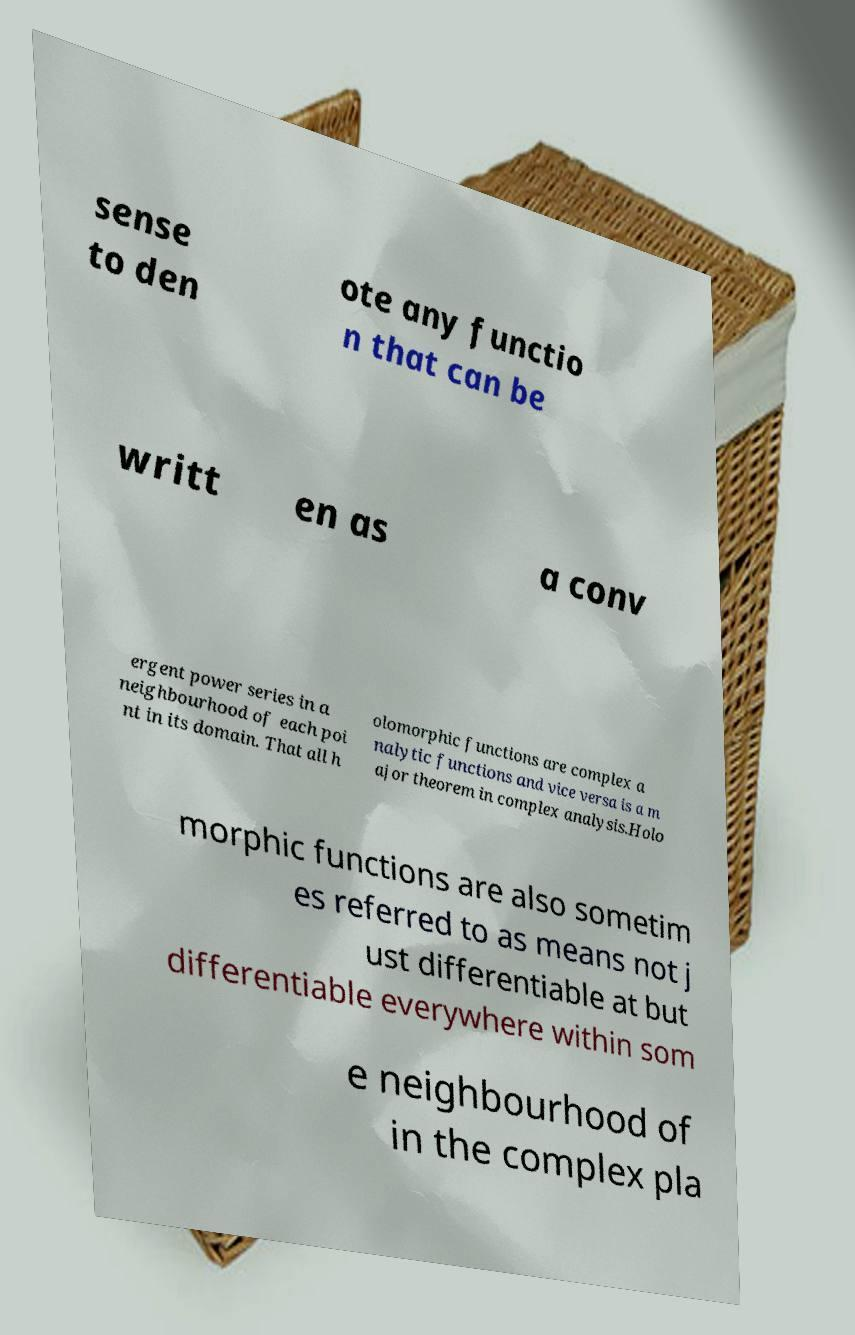Could you extract and type out the text from this image? sense to den ote any functio n that can be writt en as a conv ergent power series in a neighbourhood of each poi nt in its domain. That all h olomorphic functions are complex a nalytic functions and vice versa is a m ajor theorem in complex analysis.Holo morphic functions are also sometim es referred to as means not j ust differentiable at but differentiable everywhere within som e neighbourhood of in the complex pla 